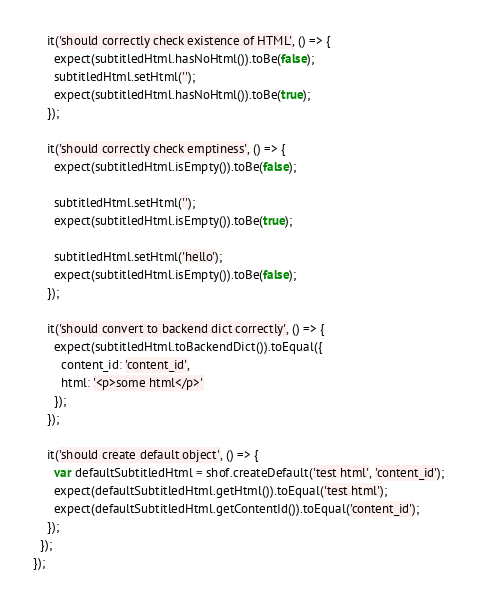Convert code to text. <code><loc_0><loc_0><loc_500><loc_500><_TypeScript_>    it('should correctly check existence of HTML', () => {
      expect(subtitledHtml.hasNoHtml()).toBe(false);
      subtitledHtml.setHtml('');
      expect(subtitledHtml.hasNoHtml()).toBe(true);
    });

    it('should correctly check emptiness', () => {
      expect(subtitledHtml.isEmpty()).toBe(false);

      subtitledHtml.setHtml('');
      expect(subtitledHtml.isEmpty()).toBe(true);

      subtitledHtml.setHtml('hello');
      expect(subtitledHtml.isEmpty()).toBe(false);
    });

    it('should convert to backend dict correctly', () => {
      expect(subtitledHtml.toBackendDict()).toEqual({
        content_id: 'content_id',
        html: '<p>some html</p>'
      });
    });

    it('should create default object', () => {
      var defaultSubtitledHtml = shof.createDefault('test html', 'content_id');
      expect(defaultSubtitledHtml.getHtml()).toEqual('test html');
      expect(defaultSubtitledHtml.getContentId()).toEqual('content_id');
    });
  });
});
</code> 